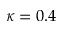Convert formula to latex. <formula><loc_0><loc_0><loc_500><loc_500>\kappa = 0 . 4</formula> 